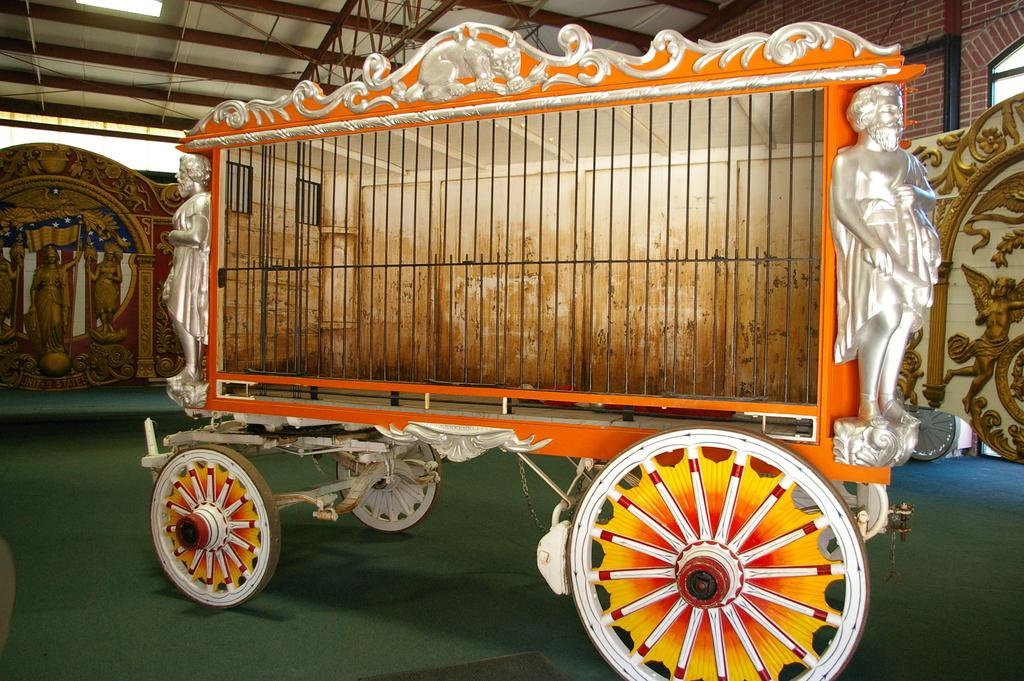What is the main object in the image? There is a cart in the image. What other objects are near the cart? There are statues beside the cart. What type of structure is visible in the image? There is a brick wall in the image. What is visible at the top of the image? The ceiling with metal frames is visible at the top of the image. What is the surface that the cart and statues are standing on? The floor is present in the image. Can you see a machine combing the hill in the image? There is no machine or hill present in the image. 